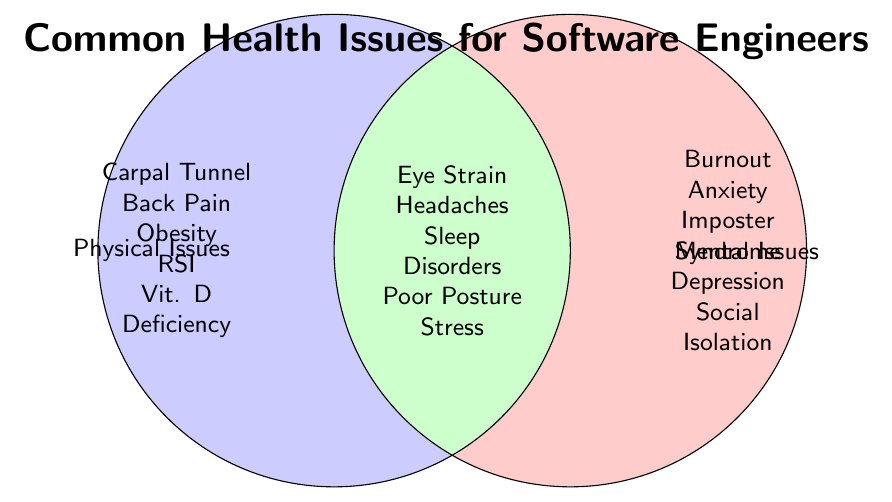What's the title of the figure? The title of the figure is found at the top and it summarizes the content shown in the Venn Diagram.
Answer: Common Health Issues for Software Engineers Which issues are listed under Physical Issues only? Under the Physical Issues circle, the issues listed are Carpal Tunnel Syndrome, Back Pain, Obesity, Repetitive Strain Injury, and Vitamin D Deficiency.
Answer: Carpal Tunnel Syndrome, Back Pain, Obesity, Repetitive Strain Injury, Vitamin D Deficiency Which issues appear under both Physical and Mental categories? Inside the overlapping section of the Venn Diagram, the issues listed are those that affect both physical and mental health of software engineers.
Answer: Eye Strain, Headaches, Sleep Disorders, Poor Posture, Stress How many issues are listed under Mental Issues only? To find the answer, count the number of issues within the Mental Issues circle that are not in the overlapping area. There are Burnout, Anxiety, Imposter Syndrome, Depression, and Social Isolation.
Answer: 5 Do both Burnout and Obesity appear in the same category? Look for both Burnout and Obesity in their respective circles in the Venn Diagram: Burnout is listed under Mental Issues, while Obesity is listed under Physical Issues.
Answer: No How many total unique health issues are mentioned? Count the total number of unique issues listed across both circles and their intersection. There are 5 Physical, 5 Mental, and 5 Both.
Answer: 15 Which category lists Poor Posture? Poor Posture appears under the overlapping area of the Venn Diagram between Physical Issues and Mental Issues, indicating it affects both categories.
Answer: Both What is the commonality between Stress and Headaches based on the figure? Both Stress and Headaches appear in the intersection of Physical Issues and Mental Issues, indicating they affect both aspects.
Answer: Both 